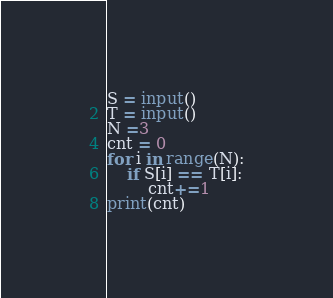Convert code to text. <code><loc_0><loc_0><loc_500><loc_500><_Python_>S = input()
T = input()
N =3
cnt = 0
for i in range(N):
    if S[i] == T[i]:
        cnt+=1
print(cnt)</code> 